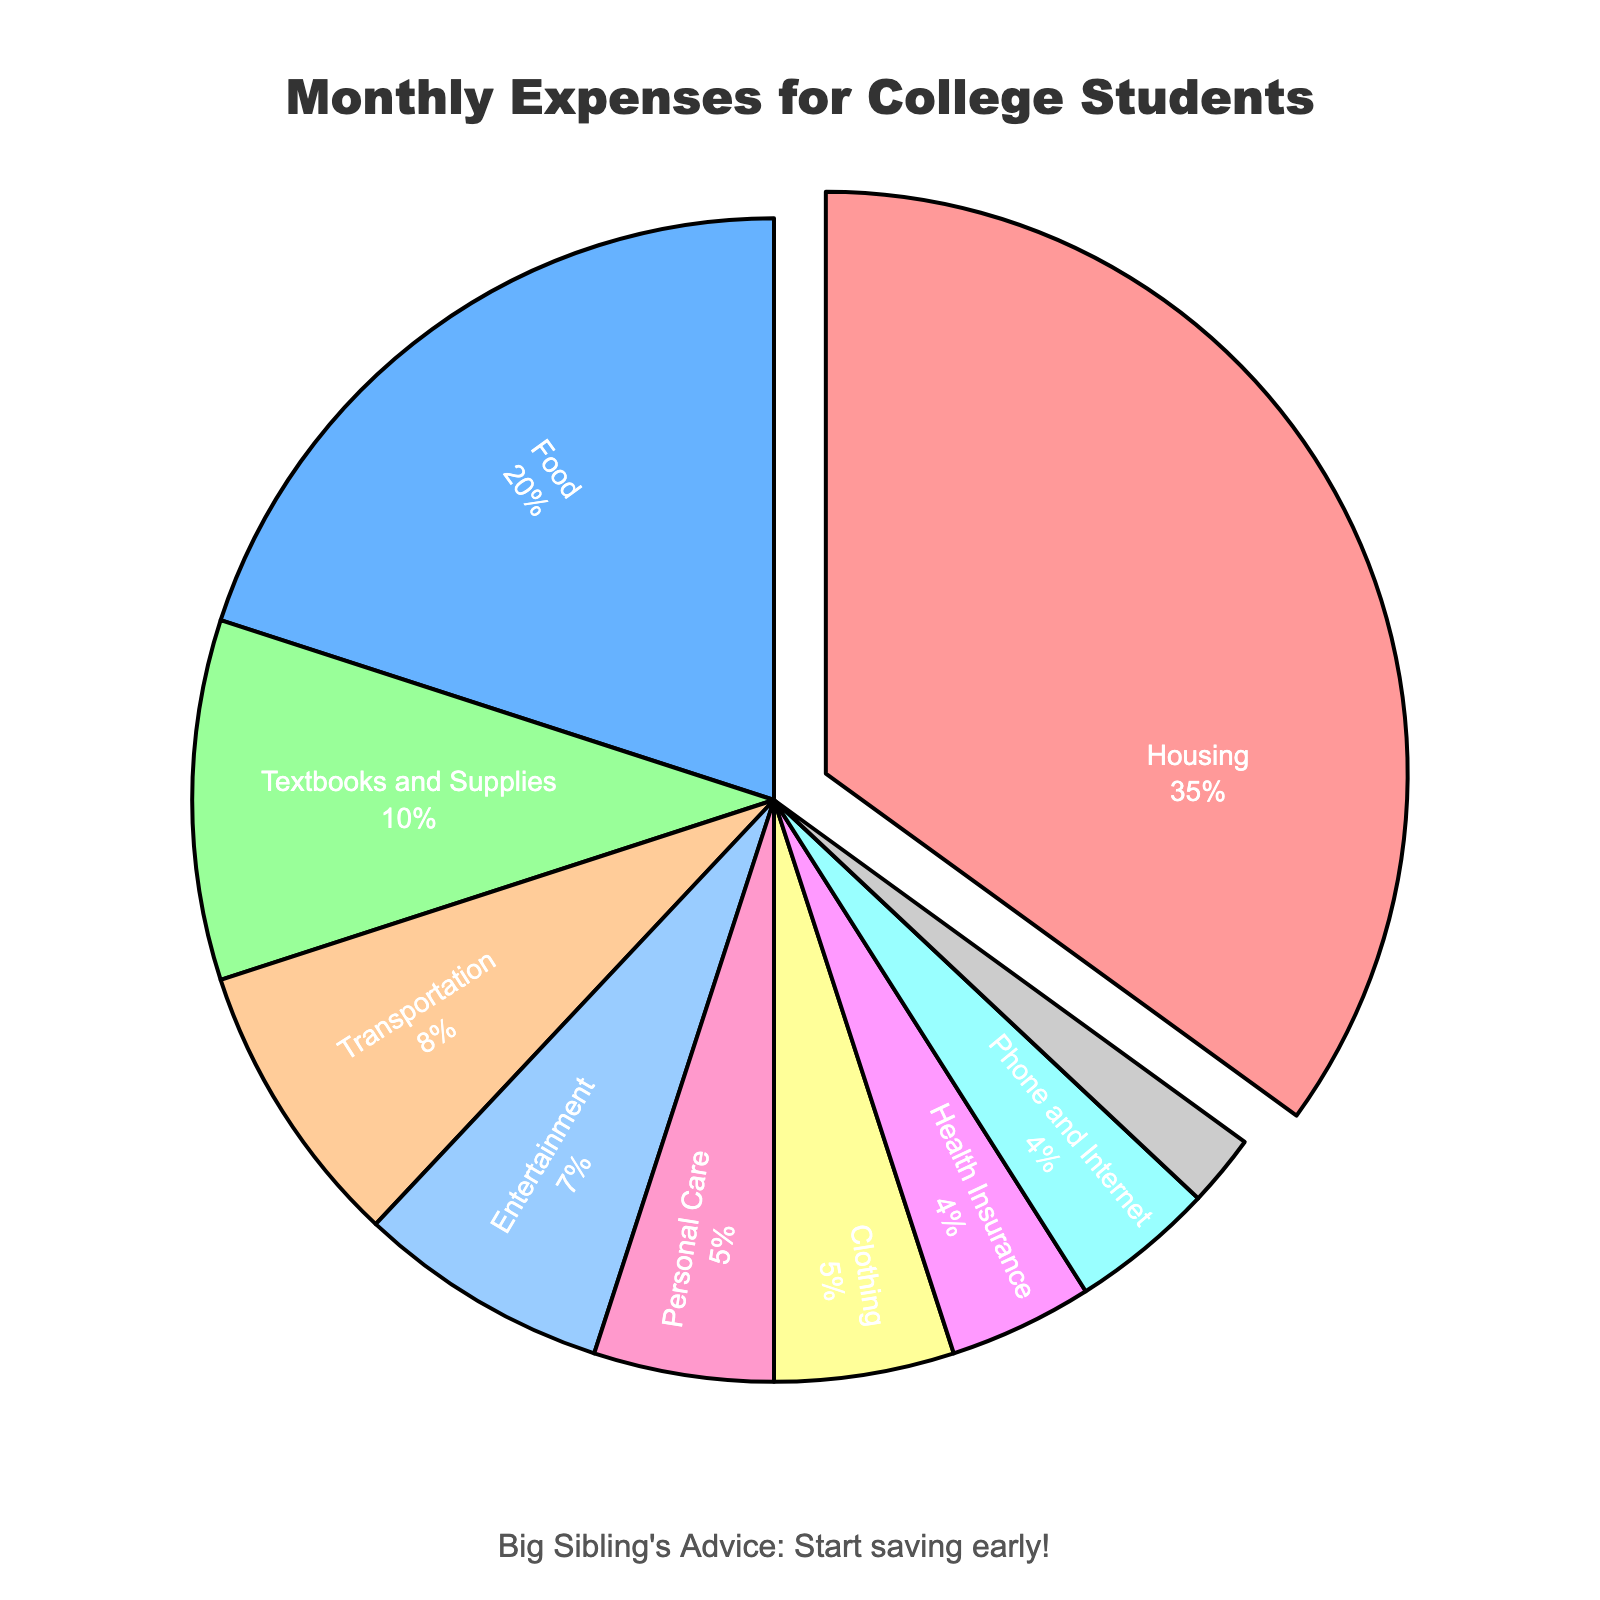Which category has the highest percentage of monthly expenses? By referring to the chart, the largest segment of the pie chart, which is separated from the rest, represents the category with the highest percentage of expenses. This segment is colored differently from the others as well.
Answer: Housing What is the combined percentage for Transportation and Personal Care? The percentage for Transportation is 8% and for Personal Care is 5%. Adding these two values gives us 8 + 5 = 13%.
Answer: 13% Which category has a smaller percentage: Clothing or Health Insurance? By observing the pie chart, the segment for Clothing is 5%, and the segment for Health Insurance is 4%. Therefore, Health Insurance has a smaller percentage.
Answer: Health Insurance What is the difference in percentage between Food and Entertainment expenses? The percentage for Food is 20% and for Entertainment is 7%. Subtracting the two percentages gives us 20 - 7 = 13%.
Answer: 13% What is the percentage allocation for the least expensive category? By looking at the pie chart, the smallest segment represents the least expensive category, which visually appears smaller than the others. The smallest segment corresponds to Savings at 2%.
Answer: 2% What is the sum of percentages for Housing, Food, and Textbooks and Supplies? Adding the percentages for Housing (35%), Food (20%), and Textbooks and Supplies (10%) provides us the sum: 35 + 20 + 10 = 65%.
Answer: 65% Which two categories have equal allocation percentages, and what is their common percentage? Observing the pie chart, we see that Clothing and Personal Care are visually equal in size, and both have an allocation of 5%.
Answer: Clothing and Personal Care, 5% What is the median value of the expense percentages? To find the median, we list out all percentages (2, 4, 4, 5, 5, 7, 8, 10, 20, 35). The median value is the middle number in a sorted list, which here are two middle values: 7 and 8. So, the median is the average of these two values (7+8)/2 = 7.5%.
Answer: 7.5% What percentage of expenses goes to Phone and Internet combined with Health Insurance? The percentages for Phone and Internet and Health Insurance are both 4%. Adding these two gives us 4 + 4 = 8%.
Answer: 8% Which categories combined have a higher percentage than Housing alone? Housing is 35%. Combined categories such as Food, Textbooks and Supplies, and Transportation together sum up to 20 (Food) + 10 (Textbooks and Supplies) + 8 (Transportation) = 38%, which is more than Housing alone.
Answer: Food, Textbooks and Supplies, Transportation 